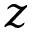<formula> <loc_0><loc_0><loc_500><loc_500>z</formula> 